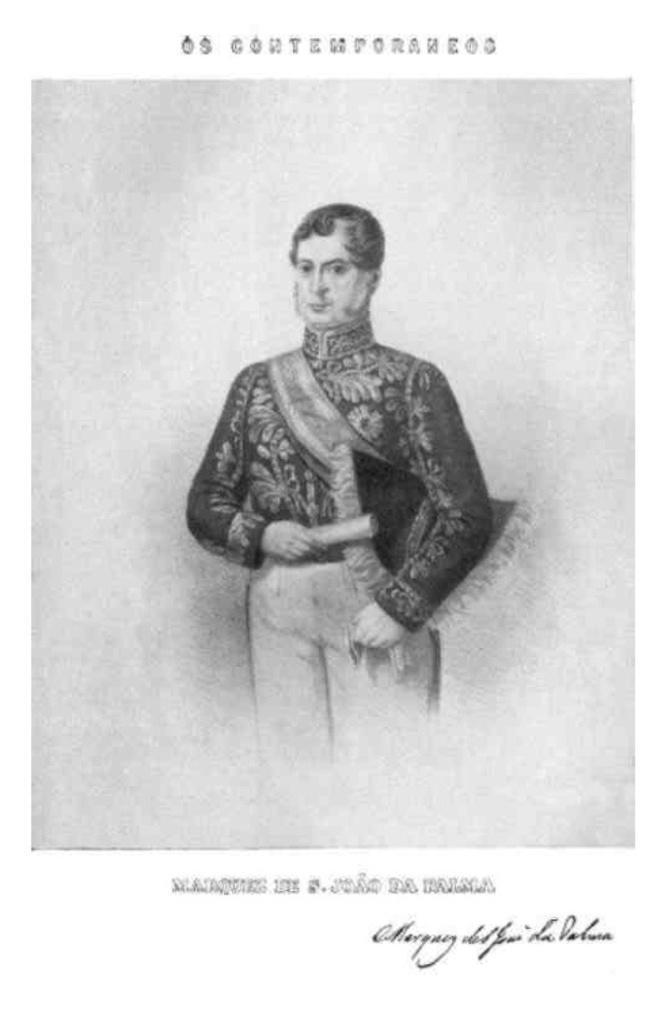Could you give a brief overview of what you see in this image? In this picture I can observe sketch of a human. I can observe text in the top and bottom of the picture. 